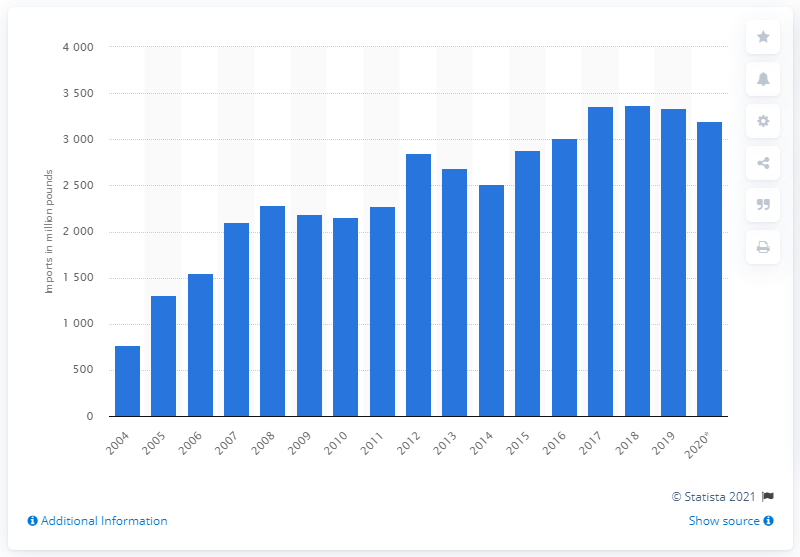Point out several critical features in this image. The United States imported 3,197 metric tons of palm oil in 2020. In 2010, the United States imported approximately 2,160 metric tons of palm oil. 